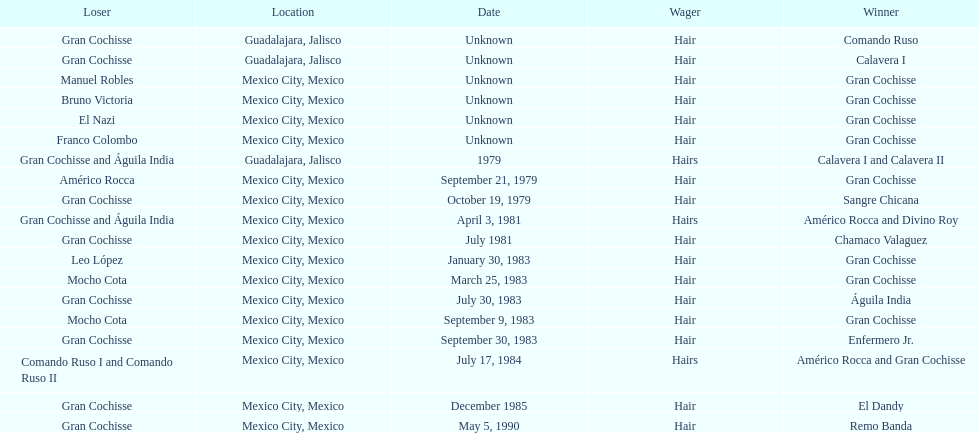How many games more than chamaco valaguez did sangre chicana win? 0. 